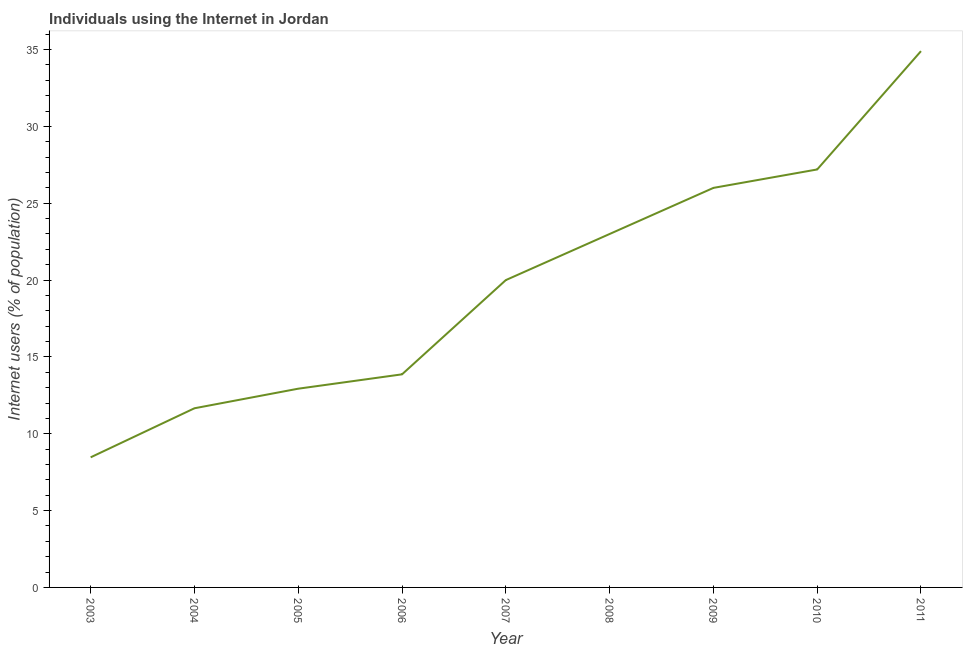What is the number of internet users in 2010?
Make the answer very short. 27.2. Across all years, what is the maximum number of internet users?
Your answer should be compact. 34.9. Across all years, what is the minimum number of internet users?
Provide a succinct answer. 8.47. In which year was the number of internet users minimum?
Offer a terse response. 2003. What is the sum of the number of internet users?
Keep it short and to the point. 178.02. What is the difference between the number of internet users in 2005 and 2011?
Provide a succinct answer. -21.97. What is the average number of internet users per year?
Keep it short and to the point. 19.78. In how many years, is the number of internet users greater than 25 %?
Offer a terse response. 3. What is the ratio of the number of internet users in 2007 to that in 2008?
Offer a very short reply. 0.87. Is the difference between the number of internet users in 2005 and 2006 greater than the difference between any two years?
Offer a very short reply. No. What is the difference between the highest and the second highest number of internet users?
Keep it short and to the point. 7.7. What is the difference between the highest and the lowest number of internet users?
Give a very brief answer. 26.43. Does the number of internet users monotonically increase over the years?
Provide a short and direct response. Yes. How many lines are there?
Your response must be concise. 1. What is the difference between two consecutive major ticks on the Y-axis?
Keep it short and to the point. 5. Does the graph contain grids?
Offer a very short reply. No. What is the title of the graph?
Your answer should be very brief. Individuals using the Internet in Jordan. What is the label or title of the Y-axis?
Make the answer very short. Internet users (% of population). What is the Internet users (% of population) of 2003?
Your answer should be very brief. 8.47. What is the Internet users (% of population) in 2004?
Keep it short and to the point. 11.66. What is the Internet users (% of population) of 2005?
Offer a very short reply. 12.93. What is the Internet users (% of population) in 2006?
Ensure brevity in your answer.  13.87. What is the Internet users (% of population) of 2008?
Keep it short and to the point. 23. What is the Internet users (% of population) in 2010?
Your answer should be very brief. 27.2. What is the Internet users (% of population) in 2011?
Ensure brevity in your answer.  34.9. What is the difference between the Internet users (% of population) in 2003 and 2004?
Make the answer very short. -3.19. What is the difference between the Internet users (% of population) in 2003 and 2005?
Make the answer very short. -4.47. What is the difference between the Internet users (% of population) in 2003 and 2006?
Offer a very short reply. -5.4. What is the difference between the Internet users (% of population) in 2003 and 2007?
Provide a short and direct response. -11.53. What is the difference between the Internet users (% of population) in 2003 and 2008?
Make the answer very short. -14.53. What is the difference between the Internet users (% of population) in 2003 and 2009?
Your response must be concise. -17.53. What is the difference between the Internet users (% of population) in 2003 and 2010?
Your answer should be very brief. -18.73. What is the difference between the Internet users (% of population) in 2003 and 2011?
Your answer should be compact. -26.43. What is the difference between the Internet users (% of population) in 2004 and 2005?
Your answer should be very brief. -1.27. What is the difference between the Internet users (% of population) in 2004 and 2006?
Provide a succinct answer. -2.21. What is the difference between the Internet users (% of population) in 2004 and 2007?
Give a very brief answer. -8.34. What is the difference between the Internet users (% of population) in 2004 and 2008?
Provide a short and direct response. -11.34. What is the difference between the Internet users (% of population) in 2004 and 2009?
Offer a terse response. -14.34. What is the difference between the Internet users (% of population) in 2004 and 2010?
Keep it short and to the point. -15.54. What is the difference between the Internet users (% of population) in 2004 and 2011?
Offer a terse response. -23.24. What is the difference between the Internet users (% of population) in 2005 and 2006?
Make the answer very short. -0.93. What is the difference between the Internet users (% of population) in 2005 and 2007?
Ensure brevity in your answer.  -7.07. What is the difference between the Internet users (% of population) in 2005 and 2008?
Offer a very short reply. -10.07. What is the difference between the Internet users (% of population) in 2005 and 2009?
Offer a very short reply. -13.07. What is the difference between the Internet users (% of population) in 2005 and 2010?
Provide a short and direct response. -14.27. What is the difference between the Internet users (% of population) in 2005 and 2011?
Make the answer very short. -21.97. What is the difference between the Internet users (% of population) in 2006 and 2007?
Keep it short and to the point. -6.13. What is the difference between the Internet users (% of population) in 2006 and 2008?
Give a very brief answer. -9.13. What is the difference between the Internet users (% of population) in 2006 and 2009?
Your answer should be compact. -12.13. What is the difference between the Internet users (% of population) in 2006 and 2010?
Ensure brevity in your answer.  -13.33. What is the difference between the Internet users (% of population) in 2006 and 2011?
Provide a short and direct response. -21.03. What is the difference between the Internet users (% of population) in 2007 and 2009?
Your answer should be very brief. -6. What is the difference between the Internet users (% of population) in 2007 and 2011?
Your answer should be compact. -14.9. What is the difference between the Internet users (% of population) in 2008 and 2009?
Keep it short and to the point. -3. What is the difference between the Internet users (% of population) in 2008 and 2011?
Offer a very short reply. -11.9. What is the difference between the Internet users (% of population) in 2010 and 2011?
Keep it short and to the point. -7.7. What is the ratio of the Internet users (% of population) in 2003 to that in 2004?
Offer a very short reply. 0.73. What is the ratio of the Internet users (% of population) in 2003 to that in 2005?
Offer a terse response. 0.66. What is the ratio of the Internet users (% of population) in 2003 to that in 2006?
Your answer should be compact. 0.61. What is the ratio of the Internet users (% of population) in 2003 to that in 2007?
Your answer should be very brief. 0.42. What is the ratio of the Internet users (% of population) in 2003 to that in 2008?
Your response must be concise. 0.37. What is the ratio of the Internet users (% of population) in 2003 to that in 2009?
Offer a very short reply. 0.33. What is the ratio of the Internet users (% of population) in 2003 to that in 2010?
Keep it short and to the point. 0.31. What is the ratio of the Internet users (% of population) in 2003 to that in 2011?
Give a very brief answer. 0.24. What is the ratio of the Internet users (% of population) in 2004 to that in 2005?
Provide a succinct answer. 0.9. What is the ratio of the Internet users (% of population) in 2004 to that in 2006?
Your answer should be very brief. 0.84. What is the ratio of the Internet users (% of population) in 2004 to that in 2007?
Offer a terse response. 0.58. What is the ratio of the Internet users (% of population) in 2004 to that in 2008?
Provide a short and direct response. 0.51. What is the ratio of the Internet users (% of population) in 2004 to that in 2009?
Give a very brief answer. 0.45. What is the ratio of the Internet users (% of population) in 2004 to that in 2010?
Your response must be concise. 0.43. What is the ratio of the Internet users (% of population) in 2004 to that in 2011?
Make the answer very short. 0.33. What is the ratio of the Internet users (% of population) in 2005 to that in 2006?
Your answer should be compact. 0.93. What is the ratio of the Internet users (% of population) in 2005 to that in 2007?
Offer a terse response. 0.65. What is the ratio of the Internet users (% of population) in 2005 to that in 2008?
Your response must be concise. 0.56. What is the ratio of the Internet users (% of population) in 2005 to that in 2009?
Offer a very short reply. 0.5. What is the ratio of the Internet users (% of population) in 2005 to that in 2010?
Your answer should be very brief. 0.47. What is the ratio of the Internet users (% of population) in 2005 to that in 2011?
Ensure brevity in your answer.  0.37. What is the ratio of the Internet users (% of population) in 2006 to that in 2007?
Provide a short and direct response. 0.69. What is the ratio of the Internet users (% of population) in 2006 to that in 2008?
Keep it short and to the point. 0.6. What is the ratio of the Internet users (% of population) in 2006 to that in 2009?
Your response must be concise. 0.53. What is the ratio of the Internet users (% of population) in 2006 to that in 2010?
Your response must be concise. 0.51. What is the ratio of the Internet users (% of population) in 2006 to that in 2011?
Offer a terse response. 0.4. What is the ratio of the Internet users (% of population) in 2007 to that in 2008?
Your answer should be compact. 0.87. What is the ratio of the Internet users (% of population) in 2007 to that in 2009?
Ensure brevity in your answer.  0.77. What is the ratio of the Internet users (% of population) in 2007 to that in 2010?
Your response must be concise. 0.73. What is the ratio of the Internet users (% of population) in 2007 to that in 2011?
Your response must be concise. 0.57. What is the ratio of the Internet users (% of population) in 2008 to that in 2009?
Your answer should be compact. 0.89. What is the ratio of the Internet users (% of population) in 2008 to that in 2010?
Make the answer very short. 0.85. What is the ratio of the Internet users (% of population) in 2008 to that in 2011?
Your answer should be very brief. 0.66. What is the ratio of the Internet users (% of population) in 2009 to that in 2010?
Keep it short and to the point. 0.96. What is the ratio of the Internet users (% of population) in 2009 to that in 2011?
Your response must be concise. 0.74. What is the ratio of the Internet users (% of population) in 2010 to that in 2011?
Your response must be concise. 0.78. 